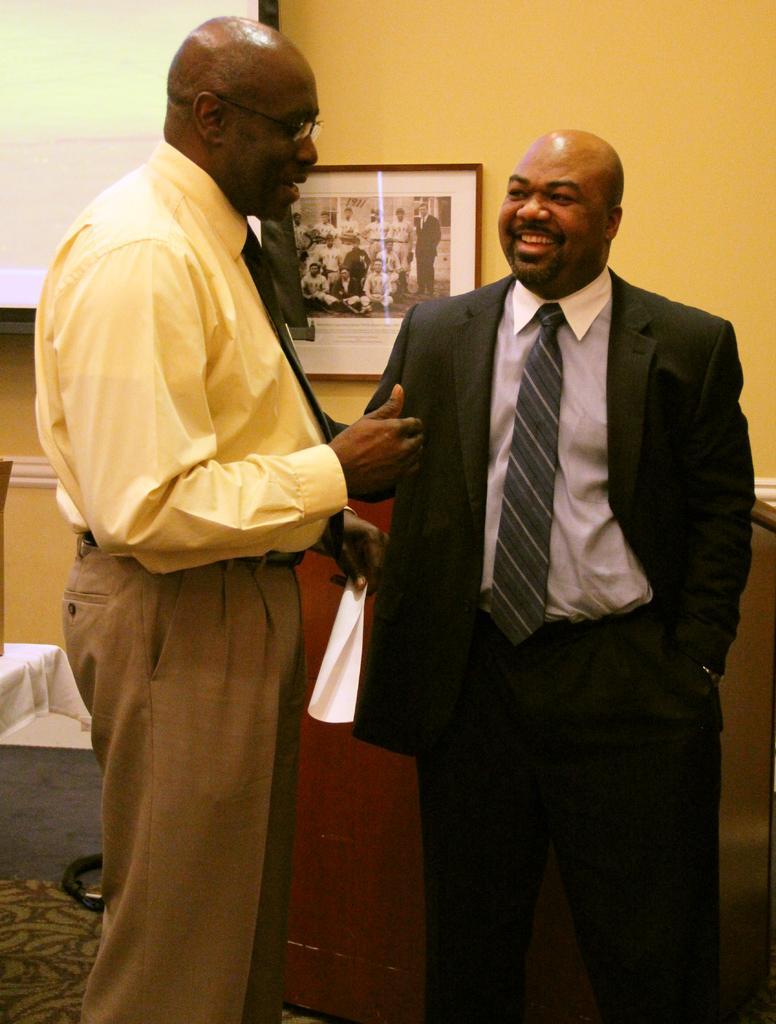How many people are present in the image? There are two persons standing in the image. What can be seen attached to the wall in the image? There is a photo frame attached to the wall in the image. What is visible in the background of the image? There is a projector in the background of the image. What type of guitar is the person playing in the image? There is no guitar present in the image; only two persons standing and a photo frame attached to the wall are visible. 